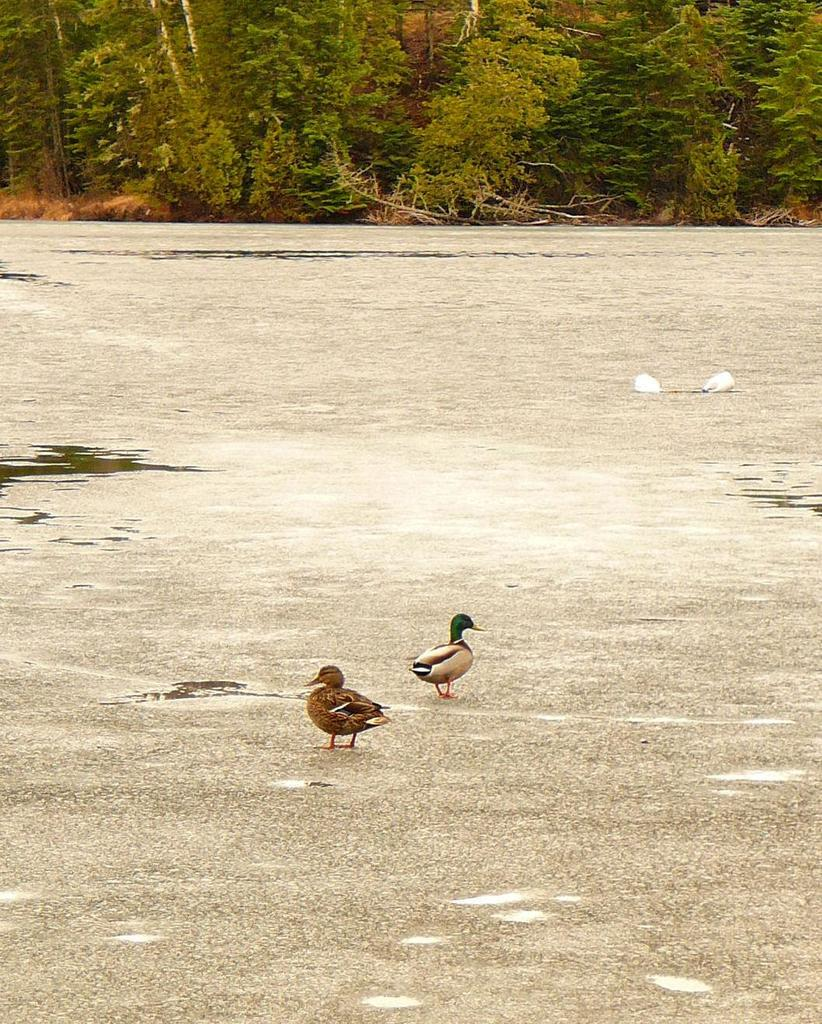What type of surface can be seen in the image? There is ground visible in the image. What is located on the ground in the image? There are objects on the ground in the image. What type of animals are present in the image? There are birds in the image. What type of vegetation is present in the image? There are trees in the image. What else can be seen in the image besides the ground and objects? There is water visible in the image. How does the drum adjust its volume during the rainstorm in the image? There is no drum or rainstorm present in the image. 